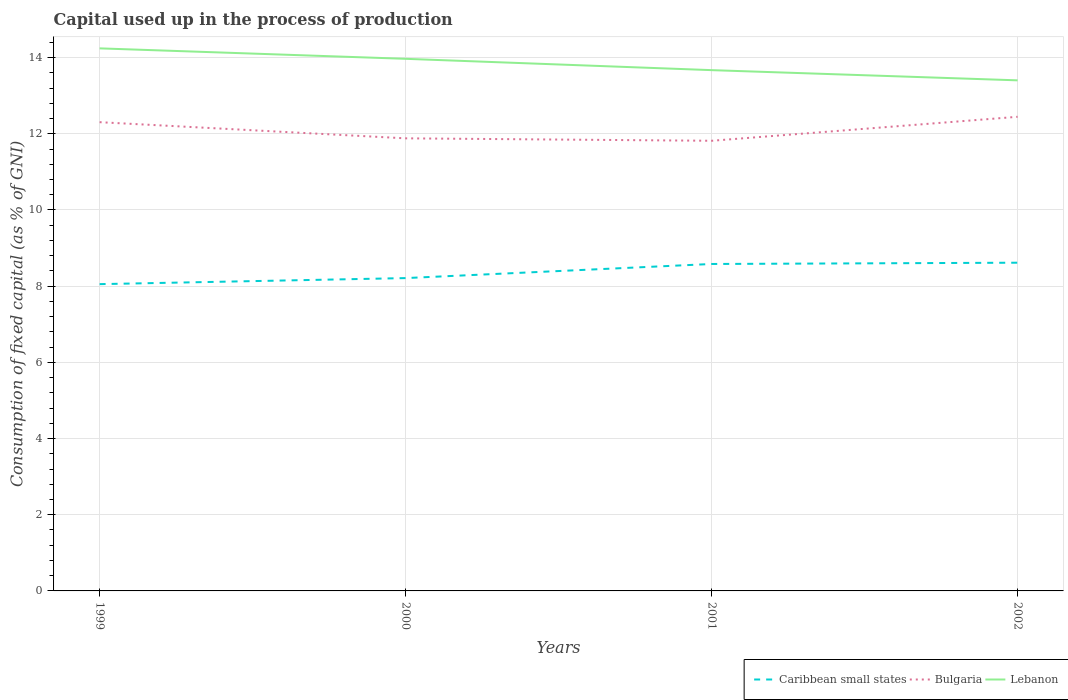Does the line corresponding to Lebanon intersect with the line corresponding to Caribbean small states?
Give a very brief answer. No. Across all years, what is the maximum capital used up in the process of production in Caribbean small states?
Provide a short and direct response. 8.05. What is the total capital used up in the process of production in Lebanon in the graph?
Provide a short and direct response. 0.84. What is the difference between the highest and the second highest capital used up in the process of production in Caribbean small states?
Provide a short and direct response. 0.56. Is the capital used up in the process of production in Caribbean small states strictly greater than the capital used up in the process of production in Bulgaria over the years?
Your answer should be compact. Yes. How many lines are there?
Your answer should be very brief. 3. How many years are there in the graph?
Keep it short and to the point. 4. Are the values on the major ticks of Y-axis written in scientific E-notation?
Your answer should be compact. No. Where does the legend appear in the graph?
Offer a very short reply. Bottom right. How are the legend labels stacked?
Offer a terse response. Horizontal. What is the title of the graph?
Ensure brevity in your answer.  Capital used up in the process of production. What is the label or title of the Y-axis?
Offer a terse response. Consumption of fixed capital (as % of GNI). What is the Consumption of fixed capital (as % of GNI) of Caribbean small states in 1999?
Keep it short and to the point. 8.05. What is the Consumption of fixed capital (as % of GNI) in Bulgaria in 1999?
Give a very brief answer. 12.3. What is the Consumption of fixed capital (as % of GNI) of Lebanon in 1999?
Give a very brief answer. 14.24. What is the Consumption of fixed capital (as % of GNI) of Caribbean small states in 2000?
Ensure brevity in your answer.  8.21. What is the Consumption of fixed capital (as % of GNI) of Bulgaria in 2000?
Your answer should be compact. 11.88. What is the Consumption of fixed capital (as % of GNI) in Lebanon in 2000?
Give a very brief answer. 13.97. What is the Consumption of fixed capital (as % of GNI) in Caribbean small states in 2001?
Your response must be concise. 8.58. What is the Consumption of fixed capital (as % of GNI) of Bulgaria in 2001?
Make the answer very short. 11.82. What is the Consumption of fixed capital (as % of GNI) in Lebanon in 2001?
Your answer should be very brief. 13.67. What is the Consumption of fixed capital (as % of GNI) in Caribbean small states in 2002?
Offer a terse response. 8.62. What is the Consumption of fixed capital (as % of GNI) of Bulgaria in 2002?
Make the answer very short. 12.45. What is the Consumption of fixed capital (as % of GNI) in Lebanon in 2002?
Make the answer very short. 13.4. Across all years, what is the maximum Consumption of fixed capital (as % of GNI) in Caribbean small states?
Offer a terse response. 8.62. Across all years, what is the maximum Consumption of fixed capital (as % of GNI) in Bulgaria?
Make the answer very short. 12.45. Across all years, what is the maximum Consumption of fixed capital (as % of GNI) in Lebanon?
Offer a terse response. 14.24. Across all years, what is the minimum Consumption of fixed capital (as % of GNI) in Caribbean small states?
Your response must be concise. 8.05. Across all years, what is the minimum Consumption of fixed capital (as % of GNI) in Bulgaria?
Offer a terse response. 11.82. Across all years, what is the minimum Consumption of fixed capital (as % of GNI) in Lebanon?
Your answer should be very brief. 13.4. What is the total Consumption of fixed capital (as % of GNI) in Caribbean small states in the graph?
Offer a terse response. 33.46. What is the total Consumption of fixed capital (as % of GNI) of Bulgaria in the graph?
Offer a terse response. 48.45. What is the total Consumption of fixed capital (as % of GNI) of Lebanon in the graph?
Your response must be concise. 55.28. What is the difference between the Consumption of fixed capital (as % of GNI) in Caribbean small states in 1999 and that in 2000?
Your answer should be very brief. -0.16. What is the difference between the Consumption of fixed capital (as % of GNI) in Bulgaria in 1999 and that in 2000?
Offer a very short reply. 0.42. What is the difference between the Consumption of fixed capital (as % of GNI) in Lebanon in 1999 and that in 2000?
Provide a short and direct response. 0.27. What is the difference between the Consumption of fixed capital (as % of GNI) in Caribbean small states in 1999 and that in 2001?
Make the answer very short. -0.53. What is the difference between the Consumption of fixed capital (as % of GNI) in Bulgaria in 1999 and that in 2001?
Your answer should be compact. 0.49. What is the difference between the Consumption of fixed capital (as % of GNI) in Lebanon in 1999 and that in 2001?
Ensure brevity in your answer.  0.57. What is the difference between the Consumption of fixed capital (as % of GNI) of Caribbean small states in 1999 and that in 2002?
Your answer should be very brief. -0.56. What is the difference between the Consumption of fixed capital (as % of GNI) in Bulgaria in 1999 and that in 2002?
Keep it short and to the point. -0.14. What is the difference between the Consumption of fixed capital (as % of GNI) of Lebanon in 1999 and that in 2002?
Provide a succinct answer. 0.84. What is the difference between the Consumption of fixed capital (as % of GNI) of Caribbean small states in 2000 and that in 2001?
Provide a succinct answer. -0.37. What is the difference between the Consumption of fixed capital (as % of GNI) in Bulgaria in 2000 and that in 2001?
Ensure brevity in your answer.  0.06. What is the difference between the Consumption of fixed capital (as % of GNI) in Lebanon in 2000 and that in 2001?
Keep it short and to the point. 0.3. What is the difference between the Consumption of fixed capital (as % of GNI) of Caribbean small states in 2000 and that in 2002?
Provide a short and direct response. -0.4. What is the difference between the Consumption of fixed capital (as % of GNI) of Bulgaria in 2000 and that in 2002?
Offer a terse response. -0.57. What is the difference between the Consumption of fixed capital (as % of GNI) in Lebanon in 2000 and that in 2002?
Offer a very short reply. 0.57. What is the difference between the Consumption of fixed capital (as % of GNI) in Caribbean small states in 2001 and that in 2002?
Give a very brief answer. -0.03. What is the difference between the Consumption of fixed capital (as % of GNI) in Bulgaria in 2001 and that in 2002?
Ensure brevity in your answer.  -0.63. What is the difference between the Consumption of fixed capital (as % of GNI) in Lebanon in 2001 and that in 2002?
Your answer should be compact. 0.27. What is the difference between the Consumption of fixed capital (as % of GNI) of Caribbean small states in 1999 and the Consumption of fixed capital (as % of GNI) of Bulgaria in 2000?
Provide a succinct answer. -3.83. What is the difference between the Consumption of fixed capital (as % of GNI) in Caribbean small states in 1999 and the Consumption of fixed capital (as % of GNI) in Lebanon in 2000?
Your response must be concise. -5.91. What is the difference between the Consumption of fixed capital (as % of GNI) in Bulgaria in 1999 and the Consumption of fixed capital (as % of GNI) in Lebanon in 2000?
Make the answer very short. -1.66. What is the difference between the Consumption of fixed capital (as % of GNI) of Caribbean small states in 1999 and the Consumption of fixed capital (as % of GNI) of Bulgaria in 2001?
Your answer should be compact. -3.76. What is the difference between the Consumption of fixed capital (as % of GNI) in Caribbean small states in 1999 and the Consumption of fixed capital (as % of GNI) in Lebanon in 2001?
Your answer should be compact. -5.62. What is the difference between the Consumption of fixed capital (as % of GNI) in Bulgaria in 1999 and the Consumption of fixed capital (as % of GNI) in Lebanon in 2001?
Make the answer very short. -1.37. What is the difference between the Consumption of fixed capital (as % of GNI) in Caribbean small states in 1999 and the Consumption of fixed capital (as % of GNI) in Bulgaria in 2002?
Offer a very short reply. -4.39. What is the difference between the Consumption of fixed capital (as % of GNI) in Caribbean small states in 1999 and the Consumption of fixed capital (as % of GNI) in Lebanon in 2002?
Your answer should be very brief. -5.35. What is the difference between the Consumption of fixed capital (as % of GNI) of Bulgaria in 1999 and the Consumption of fixed capital (as % of GNI) of Lebanon in 2002?
Keep it short and to the point. -1.1. What is the difference between the Consumption of fixed capital (as % of GNI) in Caribbean small states in 2000 and the Consumption of fixed capital (as % of GNI) in Bulgaria in 2001?
Your answer should be very brief. -3.6. What is the difference between the Consumption of fixed capital (as % of GNI) in Caribbean small states in 2000 and the Consumption of fixed capital (as % of GNI) in Lebanon in 2001?
Offer a terse response. -5.46. What is the difference between the Consumption of fixed capital (as % of GNI) of Bulgaria in 2000 and the Consumption of fixed capital (as % of GNI) of Lebanon in 2001?
Ensure brevity in your answer.  -1.79. What is the difference between the Consumption of fixed capital (as % of GNI) in Caribbean small states in 2000 and the Consumption of fixed capital (as % of GNI) in Bulgaria in 2002?
Ensure brevity in your answer.  -4.23. What is the difference between the Consumption of fixed capital (as % of GNI) of Caribbean small states in 2000 and the Consumption of fixed capital (as % of GNI) of Lebanon in 2002?
Your answer should be very brief. -5.19. What is the difference between the Consumption of fixed capital (as % of GNI) in Bulgaria in 2000 and the Consumption of fixed capital (as % of GNI) in Lebanon in 2002?
Provide a succinct answer. -1.52. What is the difference between the Consumption of fixed capital (as % of GNI) in Caribbean small states in 2001 and the Consumption of fixed capital (as % of GNI) in Bulgaria in 2002?
Provide a short and direct response. -3.86. What is the difference between the Consumption of fixed capital (as % of GNI) of Caribbean small states in 2001 and the Consumption of fixed capital (as % of GNI) of Lebanon in 2002?
Your answer should be compact. -4.82. What is the difference between the Consumption of fixed capital (as % of GNI) in Bulgaria in 2001 and the Consumption of fixed capital (as % of GNI) in Lebanon in 2002?
Provide a short and direct response. -1.59. What is the average Consumption of fixed capital (as % of GNI) in Caribbean small states per year?
Give a very brief answer. 8.37. What is the average Consumption of fixed capital (as % of GNI) in Bulgaria per year?
Provide a succinct answer. 12.11. What is the average Consumption of fixed capital (as % of GNI) of Lebanon per year?
Your answer should be compact. 13.82. In the year 1999, what is the difference between the Consumption of fixed capital (as % of GNI) in Caribbean small states and Consumption of fixed capital (as % of GNI) in Bulgaria?
Give a very brief answer. -4.25. In the year 1999, what is the difference between the Consumption of fixed capital (as % of GNI) in Caribbean small states and Consumption of fixed capital (as % of GNI) in Lebanon?
Give a very brief answer. -6.19. In the year 1999, what is the difference between the Consumption of fixed capital (as % of GNI) of Bulgaria and Consumption of fixed capital (as % of GNI) of Lebanon?
Your answer should be very brief. -1.94. In the year 2000, what is the difference between the Consumption of fixed capital (as % of GNI) of Caribbean small states and Consumption of fixed capital (as % of GNI) of Bulgaria?
Your answer should be very brief. -3.67. In the year 2000, what is the difference between the Consumption of fixed capital (as % of GNI) of Caribbean small states and Consumption of fixed capital (as % of GNI) of Lebanon?
Give a very brief answer. -5.76. In the year 2000, what is the difference between the Consumption of fixed capital (as % of GNI) of Bulgaria and Consumption of fixed capital (as % of GNI) of Lebanon?
Keep it short and to the point. -2.09. In the year 2001, what is the difference between the Consumption of fixed capital (as % of GNI) in Caribbean small states and Consumption of fixed capital (as % of GNI) in Bulgaria?
Your answer should be very brief. -3.23. In the year 2001, what is the difference between the Consumption of fixed capital (as % of GNI) in Caribbean small states and Consumption of fixed capital (as % of GNI) in Lebanon?
Offer a very short reply. -5.09. In the year 2001, what is the difference between the Consumption of fixed capital (as % of GNI) of Bulgaria and Consumption of fixed capital (as % of GNI) of Lebanon?
Make the answer very short. -1.85. In the year 2002, what is the difference between the Consumption of fixed capital (as % of GNI) of Caribbean small states and Consumption of fixed capital (as % of GNI) of Bulgaria?
Your answer should be compact. -3.83. In the year 2002, what is the difference between the Consumption of fixed capital (as % of GNI) in Caribbean small states and Consumption of fixed capital (as % of GNI) in Lebanon?
Make the answer very short. -4.79. In the year 2002, what is the difference between the Consumption of fixed capital (as % of GNI) of Bulgaria and Consumption of fixed capital (as % of GNI) of Lebanon?
Offer a very short reply. -0.96. What is the ratio of the Consumption of fixed capital (as % of GNI) in Caribbean small states in 1999 to that in 2000?
Your answer should be very brief. 0.98. What is the ratio of the Consumption of fixed capital (as % of GNI) in Bulgaria in 1999 to that in 2000?
Offer a very short reply. 1.04. What is the ratio of the Consumption of fixed capital (as % of GNI) of Lebanon in 1999 to that in 2000?
Provide a succinct answer. 1.02. What is the ratio of the Consumption of fixed capital (as % of GNI) in Caribbean small states in 1999 to that in 2001?
Your answer should be compact. 0.94. What is the ratio of the Consumption of fixed capital (as % of GNI) in Bulgaria in 1999 to that in 2001?
Provide a succinct answer. 1.04. What is the ratio of the Consumption of fixed capital (as % of GNI) in Lebanon in 1999 to that in 2001?
Ensure brevity in your answer.  1.04. What is the ratio of the Consumption of fixed capital (as % of GNI) of Caribbean small states in 1999 to that in 2002?
Give a very brief answer. 0.93. What is the ratio of the Consumption of fixed capital (as % of GNI) in Bulgaria in 1999 to that in 2002?
Your answer should be compact. 0.99. What is the ratio of the Consumption of fixed capital (as % of GNI) of Lebanon in 1999 to that in 2002?
Give a very brief answer. 1.06. What is the ratio of the Consumption of fixed capital (as % of GNI) of Caribbean small states in 2000 to that in 2001?
Make the answer very short. 0.96. What is the ratio of the Consumption of fixed capital (as % of GNI) in Bulgaria in 2000 to that in 2001?
Offer a very short reply. 1.01. What is the ratio of the Consumption of fixed capital (as % of GNI) in Lebanon in 2000 to that in 2001?
Keep it short and to the point. 1.02. What is the ratio of the Consumption of fixed capital (as % of GNI) in Caribbean small states in 2000 to that in 2002?
Your answer should be compact. 0.95. What is the ratio of the Consumption of fixed capital (as % of GNI) in Bulgaria in 2000 to that in 2002?
Keep it short and to the point. 0.95. What is the ratio of the Consumption of fixed capital (as % of GNI) of Lebanon in 2000 to that in 2002?
Make the answer very short. 1.04. What is the ratio of the Consumption of fixed capital (as % of GNI) of Bulgaria in 2001 to that in 2002?
Offer a terse response. 0.95. What is the ratio of the Consumption of fixed capital (as % of GNI) in Lebanon in 2001 to that in 2002?
Provide a short and direct response. 1.02. What is the difference between the highest and the second highest Consumption of fixed capital (as % of GNI) in Caribbean small states?
Offer a terse response. 0.03. What is the difference between the highest and the second highest Consumption of fixed capital (as % of GNI) in Bulgaria?
Provide a succinct answer. 0.14. What is the difference between the highest and the second highest Consumption of fixed capital (as % of GNI) in Lebanon?
Provide a succinct answer. 0.27. What is the difference between the highest and the lowest Consumption of fixed capital (as % of GNI) in Caribbean small states?
Provide a short and direct response. 0.56. What is the difference between the highest and the lowest Consumption of fixed capital (as % of GNI) of Bulgaria?
Offer a terse response. 0.63. What is the difference between the highest and the lowest Consumption of fixed capital (as % of GNI) of Lebanon?
Provide a short and direct response. 0.84. 